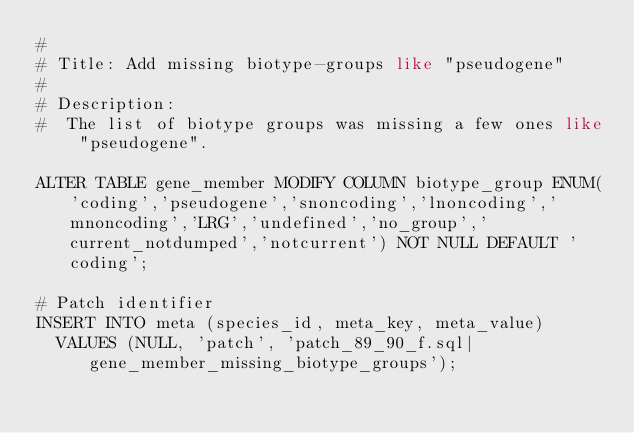Convert code to text. <code><loc_0><loc_0><loc_500><loc_500><_SQL_>#
# Title: Add missing biotype-groups like "pseudogene"
#
# Description:
#  The list of biotype groups was missing a few ones like "pseudogene".

ALTER TABLE gene_member MODIFY COLUMN biotype_group ENUM('coding','pseudogene','snoncoding','lnoncoding','mnoncoding','LRG','undefined','no_group','current_notdumped','notcurrent') NOT NULL DEFAULT 'coding';

# Patch identifier
INSERT INTO meta (species_id, meta_key, meta_value)
  VALUES (NULL, 'patch', 'patch_89_90_f.sql|gene_member_missing_biotype_groups');
</code> 